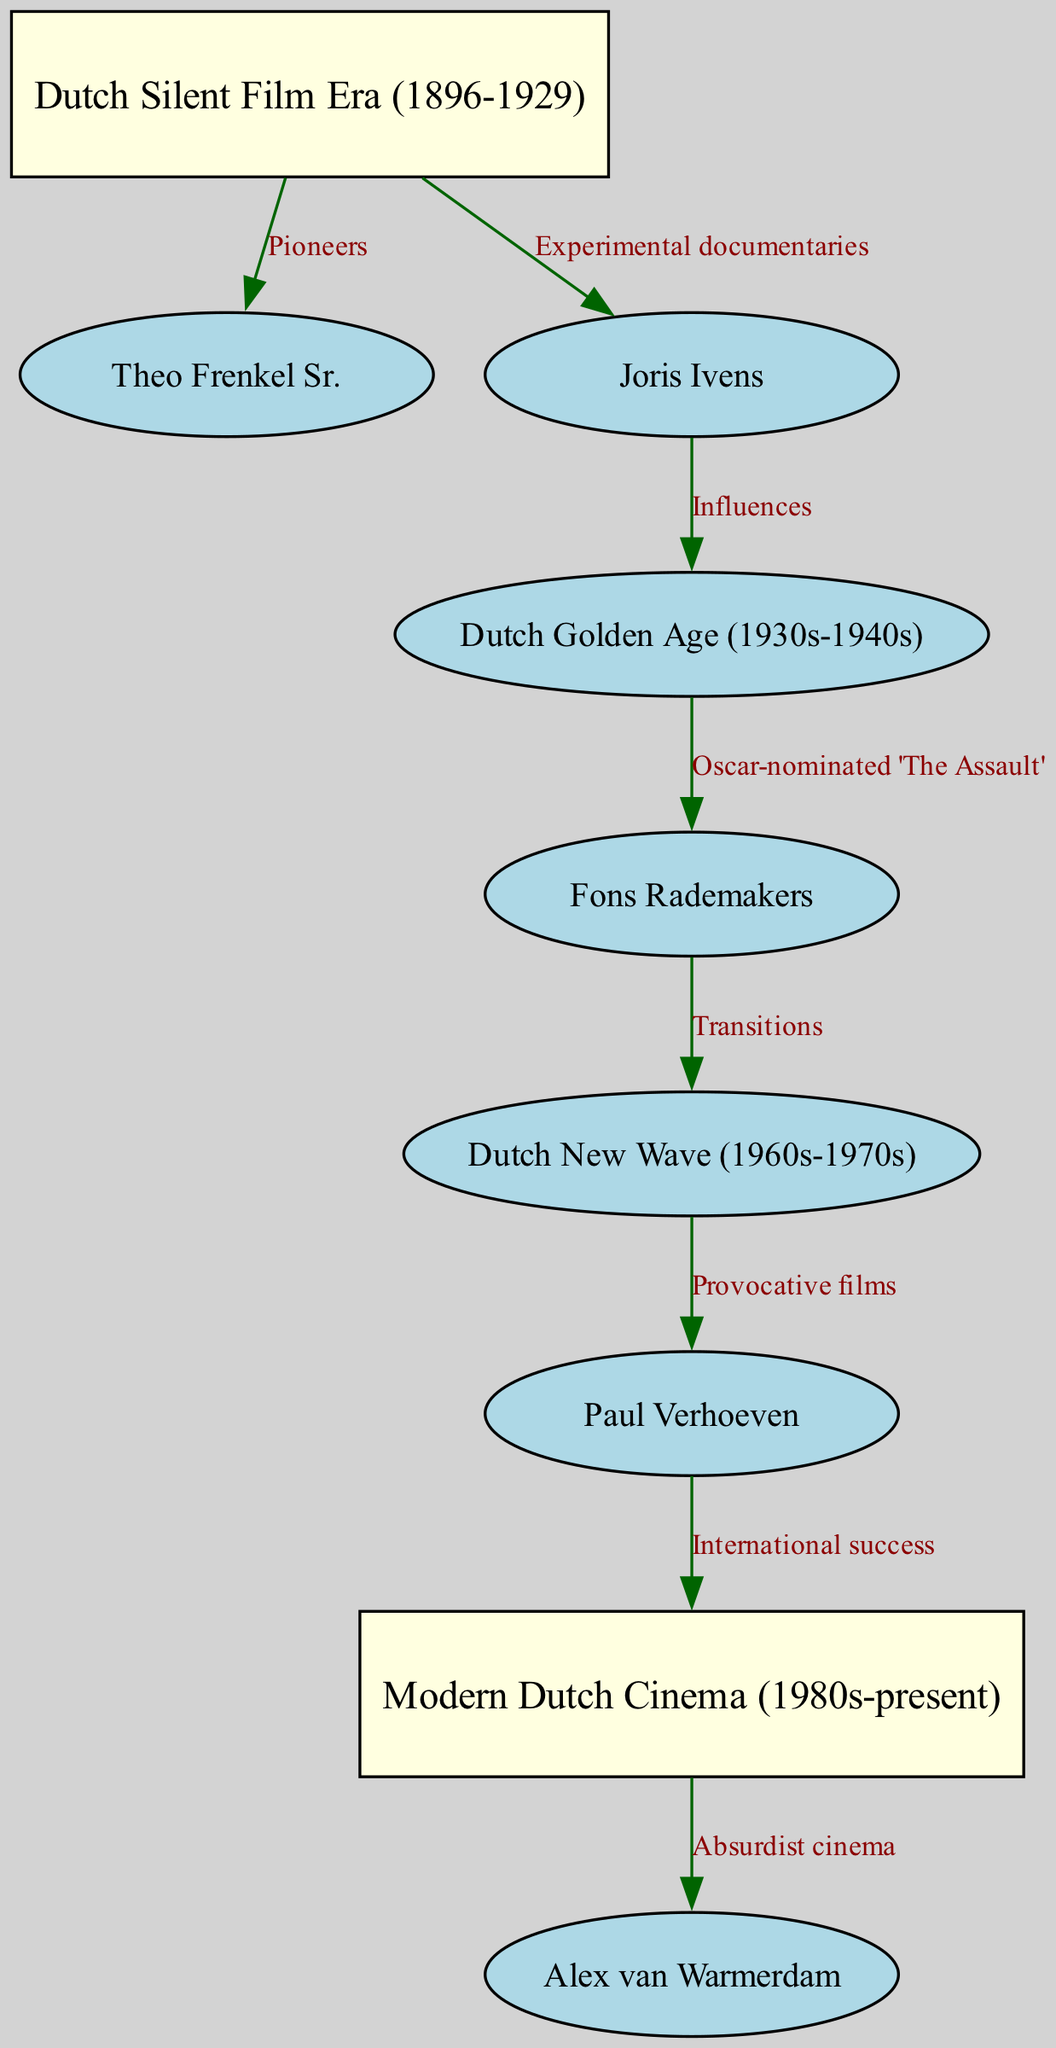What is the first era depicted in the diagram? The diagram clearly shows "Dutch Silent Film Era (1896-1929)" as the first node connected to others, indicating the starting point of the evolution of Dutch cinema.
Answer: Dutch Silent Film Era (1896-1929) How many nodes are present in the diagram? By counting each entry in the "nodes" section of the data, I find that there are a total of eight nodes representing different eras and directors.
Answer: 8 Who directed 'The Assault'? The label from the edge connected to the "GoldenAge" node shows that "Fons Rademakers" is linked to the Oscar-nominated film 'The Assault', identifying him as the director.
Answer: Fons Rademakers Which director is associated with the influence of "Experimental documentaries"? The directed edge from the "SilentEra" node to "Joris Ivens" indicates that Ivens is recognized for his experimental documentaries, directly connecting him to the early era of cinema.
Answer: Joris Ivens What is the primary output of Paul Verhoeven's work? The diagram links the "NewWave" node to "Paul Verhoeven" with the label "Provocative films", and further connects him to the "ModernEra" with "International success", showing what he is primarily known for.
Answer: International success Which era follows the Dutch Golden Age? Observing the structure of the diagram, the directed edge indicates that the "Dutch New Wave (1960s-1970s)" is the next era after the "GoldenAge".
Answer: Dutch New Wave (1960s-1970s) How does 'The Assault' influence later cinema? The relationship depicted shows that 'The Assault' directed by Fons Rademakers leads to the "Transitions" toward the "NewWave", indicating its influence on later films and movements in Dutch cinema.
Answer: Transitions Which director is known for Absurdist cinema in the Modern Era? The diagram illustrates that "Alex van Warmerdam" is directly connected to the "ModernEra" node with the label "Absurdist cinema", specifying his role in this contemporary context.
Answer: Alex van Warmerdam 